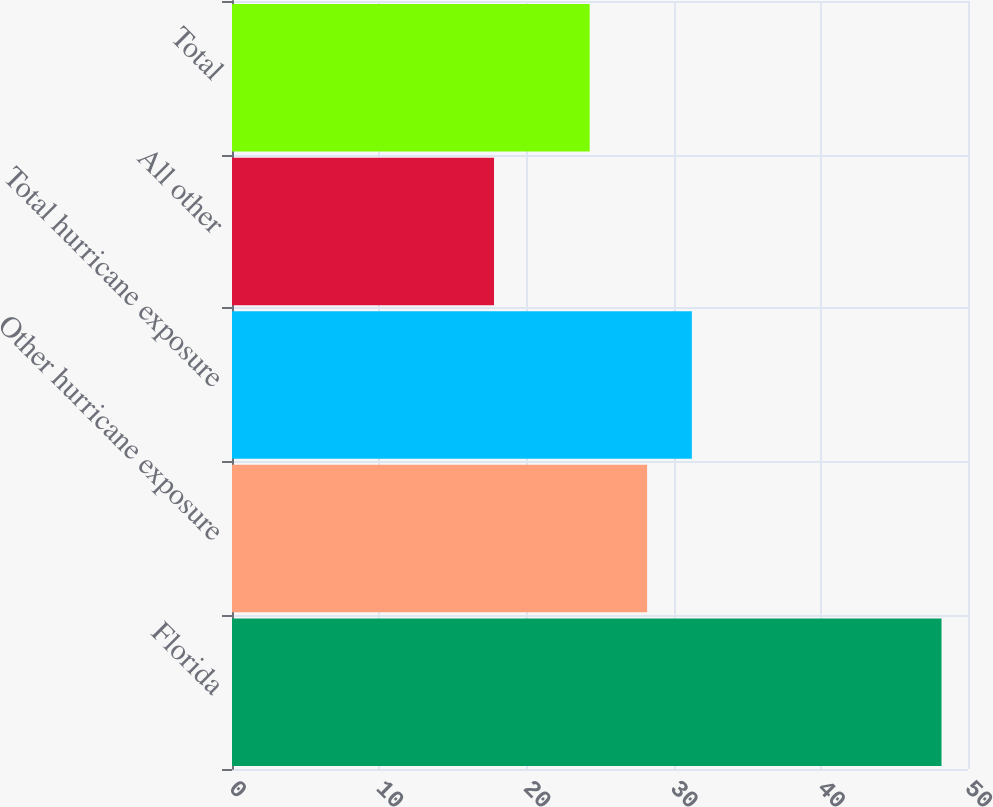<chart> <loc_0><loc_0><loc_500><loc_500><bar_chart><fcel>Florida<fcel>Other hurricane exposure<fcel>Total hurricane exposure<fcel>All other<fcel>Total<nl><fcel>48.2<fcel>28.2<fcel>31.24<fcel>17.8<fcel>24.3<nl></chart> 